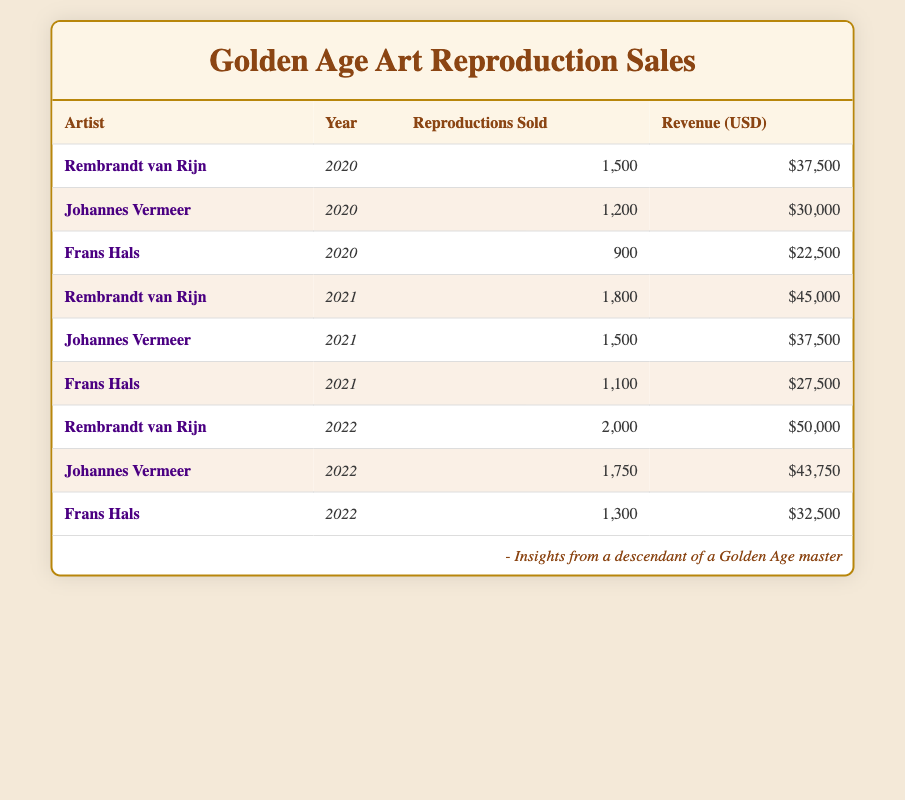What was the total revenue generated by Rembrandt van Rijn in 2020? According to the table, Rembrandt van Rijn sold 1,500 reproductions in 2020, generating a revenue of $37,500. So the total revenue for Rembrandt in that year is directly taken from the relevant row.
Answer: $37,500 Which artist had the most reproductions sold in 2022? In 2022, Rembrandt van Rijn sold 2,000 reproductions, Johannes Vermeer sold 1,750, and Frans Hals sold 1,300. Comparing these values shows that Rembrandt van Rijn had the highest sales.
Answer: Rembrandt van Rijn What is the total number of reproductions sold by all artists in 2021? Summing the reproductions sold in 2021, we have: 1,800 (Rembrandt) + 1,500 (Vermeer) + 1,100 (Hals) = 4,400. Thus, the total number of reproductions sold by all artists in that year is calculated by adding up all contributions from each artist.
Answer: 4,400 Did Frans Hals generate more revenue in 2020 than in 2021? In 2020, Frans Hals generated $22,500, and in 2021, he generated $27,500. Comparing these two revenues shows that $22,500 is less than $27,500, hence he did not generate more revenue in 2020 than in 2021.
Answer: No What is the average number of reproductions sold by Johannes Vermeer over the three years? Johannes Vermeer sold 1,200 in 2020, 1,500 in 2021, and 1,750 in 2022. To find the average, we sum these sales: 1,200 + 1,500 + 1,750 = 4,450, and then divide by 3 (the number of years): 4,450 / 3 = 1,483.33. Thus, we calculate the average by adding the values and dividing by the count of years.
Answer: 1,483.33 How much more revenue did Rembrandt van Rijn generate than Frans Hals in 2022? In 2022, Rembrandt van Rijn generated $50,000, and Frans Hals generated $32,500. To find the difference, we subtract Hals's revenue from Rembrandt's: $50,000 - $32,500 = $17,500. Thus, calculating the revenue difference shows how much more Rembrandt earned that year.
Answer: $17,500 Was the total revenue from reproductions in 2020 higher than in 2021? The total revenue for 2020 is calculated as follows: $37,500 (Rembrandt) + $30,000 (Vermeer) + $22,500 (Hals) = $90,000. For 2021: $45,000 (Rembrandt) + $37,500 (Vermeer) + $27,500 (Hals) = $110,000. Since $90,000 is less than $110,000, the total revenue was not higher in 2020 than in 2021.
Answer: No What was the percentage increase in reproductions sold by Rembrandt van Rijn from 2020 to 2022? In 2020, Rembrandt sold 1,500 reproductions, and in 2022, he sold 2,000. The increase is 2,000 - 1,500 = 500. To find the percentage increase, we divide the increase by the original number and then multiply by 100: (500 / 1,500) * 100 = 33.33%. Hence, this percentage indicates how much more he sold in 2022 relative to his sales in 2020.
Answer: 33.33% 